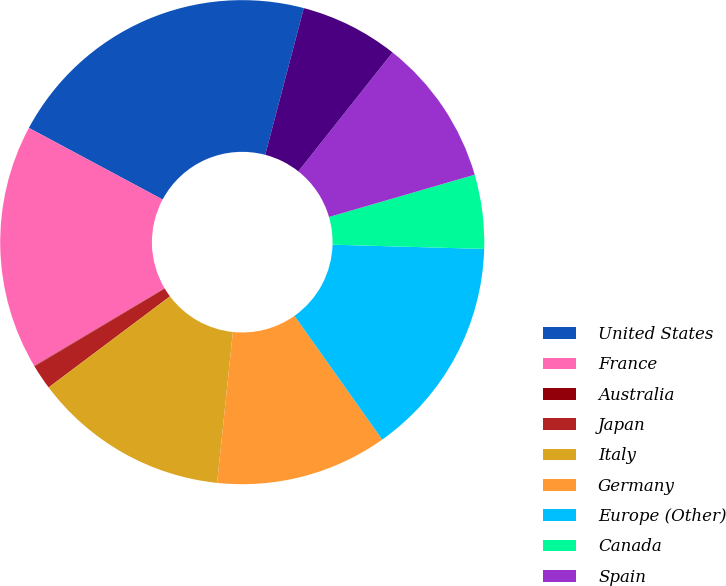Convert chart to OTSL. <chart><loc_0><loc_0><loc_500><loc_500><pie_chart><fcel>United States<fcel>France<fcel>Australia<fcel>Japan<fcel>Italy<fcel>Germany<fcel>Europe (Other)<fcel>Canada<fcel>Spain<fcel>Mexico<nl><fcel>21.27%<fcel>16.37%<fcel>0.03%<fcel>1.67%<fcel>13.1%<fcel>11.47%<fcel>14.74%<fcel>4.94%<fcel>9.84%<fcel>6.57%<nl></chart> 